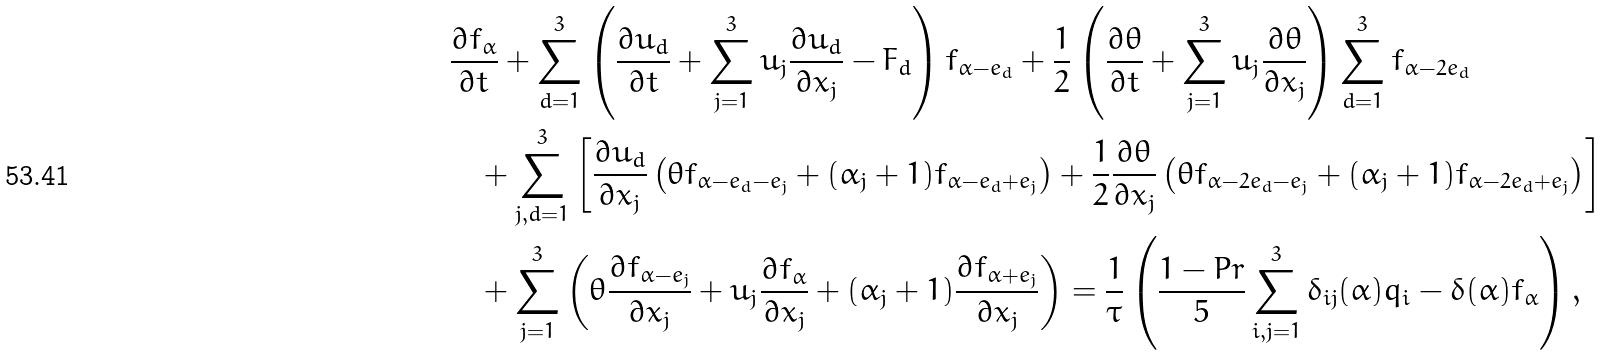<formula> <loc_0><loc_0><loc_500><loc_500>& \frac { \partial f _ { \alpha } } { \partial t } + \sum _ { d = 1 } ^ { 3 } \left ( \frac { \partial u _ { d } } { \partial t } + \sum _ { j = 1 } ^ { 3 } u _ { j } \frac { \partial u _ { d } } { \partial x _ { j } } - F _ { d } \right ) f _ { \alpha - e _ { d } } + \frac { 1 } { 2 } \left ( \frac { \partial \theta } { \partial t } + \sum _ { j = 1 } ^ { 3 } u _ { j } \frac { \partial \theta } { \partial x _ { j } } \right ) \sum _ { d = 1 } ^ { 3 } f _ { \alpha - 2 e _ { d } } \\ & \quad + \sum _ { j , d = 1 } ^ { 3 } \left [ \frac { \partial u _ { d } } { \partial x _ { j } } \left ( \theta f _ { \alpha - e _ { d } - e _ { j } } + ( \alpha _ { j } + 1 ) f _ { \alpha - e _ { d } + e _ { j } } \right ) + \frac { 1 } { 2 } \frac { \partial \theta } { \partial x _ { j } } \left ( \theta f _ { \alpha - 2 e _ { d } - e _ { j } } + ( \alpha _ { j } + 1 ) f _ { \alpha - 2 e _ { d } + e _ { j } } \right ) \right ] \\ & \quad + \sum _ { j = 1 } ^ { 3 } \left ( \theta \frac { \partial f _ { \alpha - e _ { j } } } { \partial x _ { j } } + u _ { j } \frac { \partial f _ { \alpha } } { \partial x _ { j } } + ( \alpha _ { j } + 1 ) \frac { \partial f _ { \alpha + e _ { j } } } { \partial x _ { j } } \right ) = \frac { 1 } { \tau } \left ( \frac { 1 - P r } { 5 } \sum _ { i , j = 1 } ^ { 3 } \delta _ { i j } ( \alpha ) q _ { i } - \delta ( \alpha ) f _ { \alpha } \right ) ,</formula> 